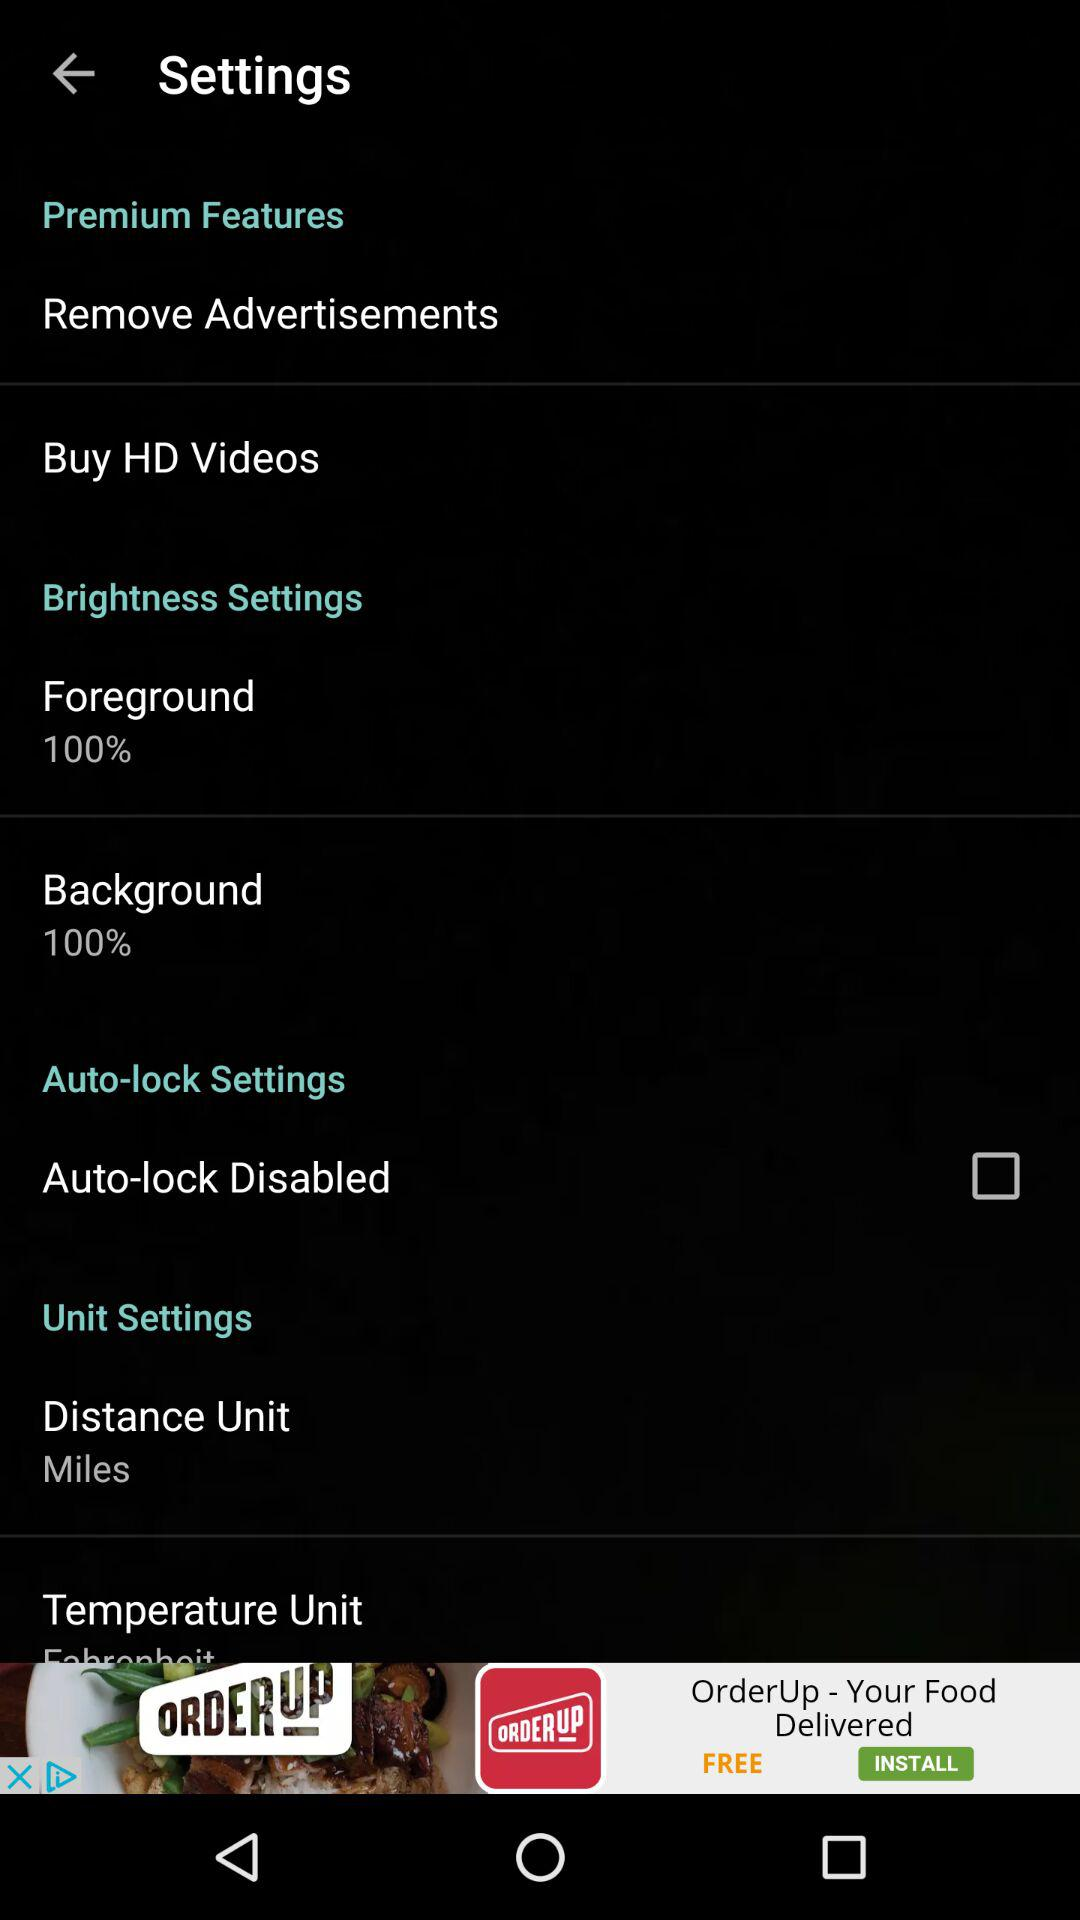What is the distance unit set to?
Answer the question using a single word or phrase. Miles 